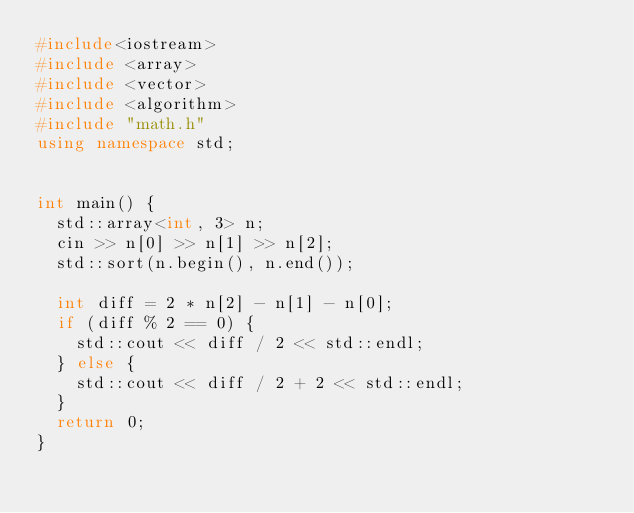<code> <loc_0><loc_0><loc_500><loc_500><_C++_>#include<iostream>
#include <array>
#include <vector>
#include <algorithm>
#include "math.h"
using namespace std;


int main() {
  std::array<int, 3> n;
  cin >> n[0] >> n[1] >> n[2];
  std::sort(n.begin(), n.end());

  int diff = 2 * n[2] - n[1] - n[0];
  if (diff % 2 == 0) {
    std::cout << diff / 2 << std::endl;
  } else {
    std::cout << diff / 2 + 2 << std::endl;
  }
  return 0;
}</code> 